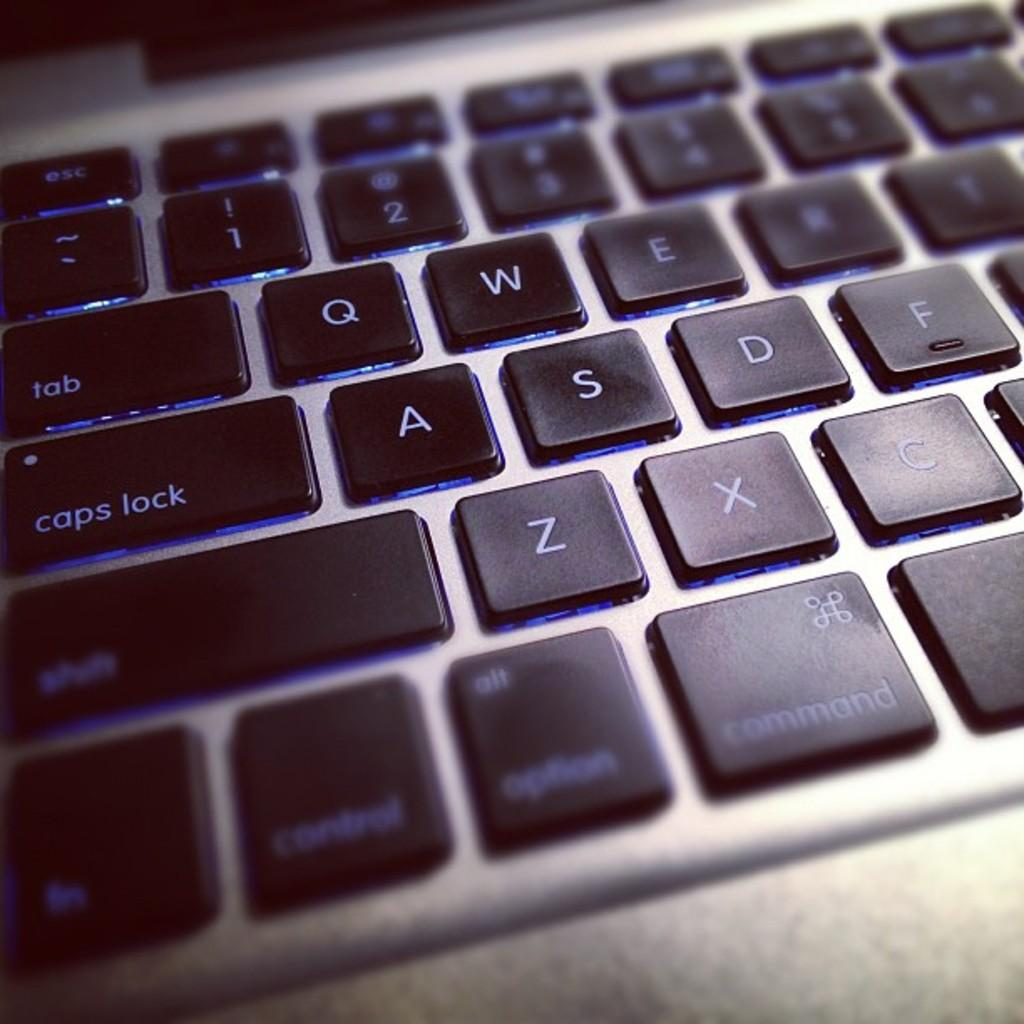Provide a one-sentence caption for the provided image. A laptop keyboard with blue keys that say tab, caps lock, shift, and more. 